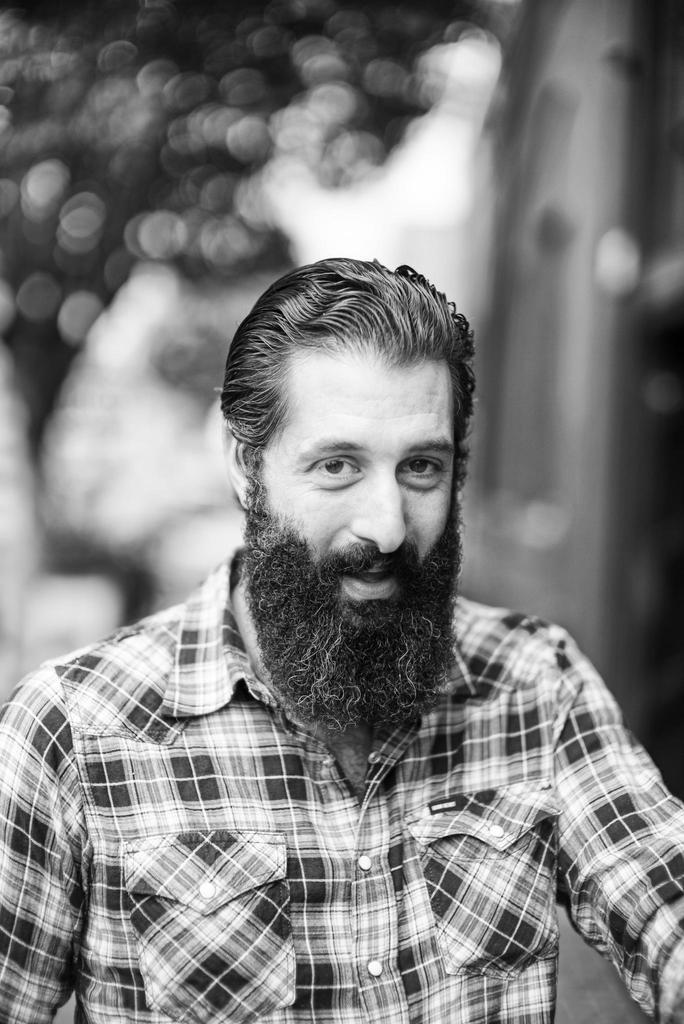Who is present in the image? There is a man in the image. What is the man wearing? The man is wearing a shirt. Can you describe the background of the image? The background of the image is blurred. What is the color scheme of the image? The image is black and white in color. What type of icicle can be seen hanging from the man's shirt in the image? There is no icicle present in the image; it is a black and white image of a man wearing a shirt. What kind of drum is the man playing in the image? There is no drum present in the image; it is a black and white image of a man wearing a shirt. 